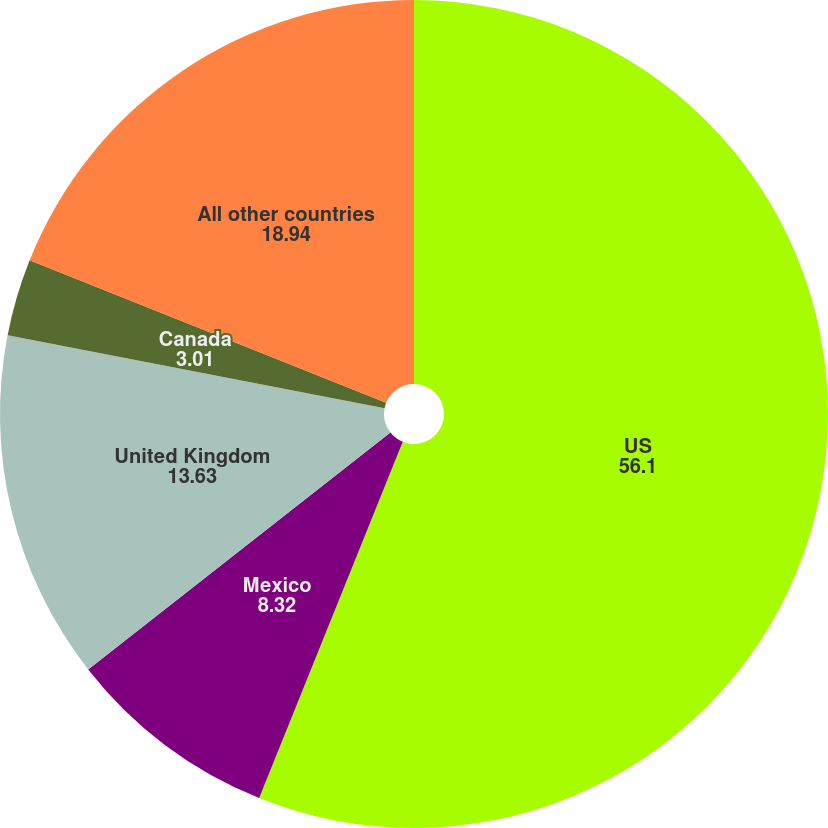<chart> <loc_0><loc_0><loc_500><loc_500><pie_chart><fcel>US<fcel>Mexico<fcel>United Kingdom<fcel>Canada<fcel>All other countries<nl><fcel>56.1%<fcel>8.32%<fcel>13.63%<fcel>3.01%<fcel>18.94%<nl></chart> 